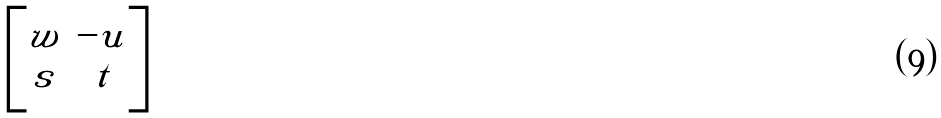<formula> <loc_0><loc_0><loc_500><loc_500>\begin{bmatrix} w & - u \\ s & t \end{bmatrix}</formula> 